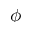Convert formula to latex. <formula><loc_0><loc_0><loc_500><loc_500>\phi</formula> 